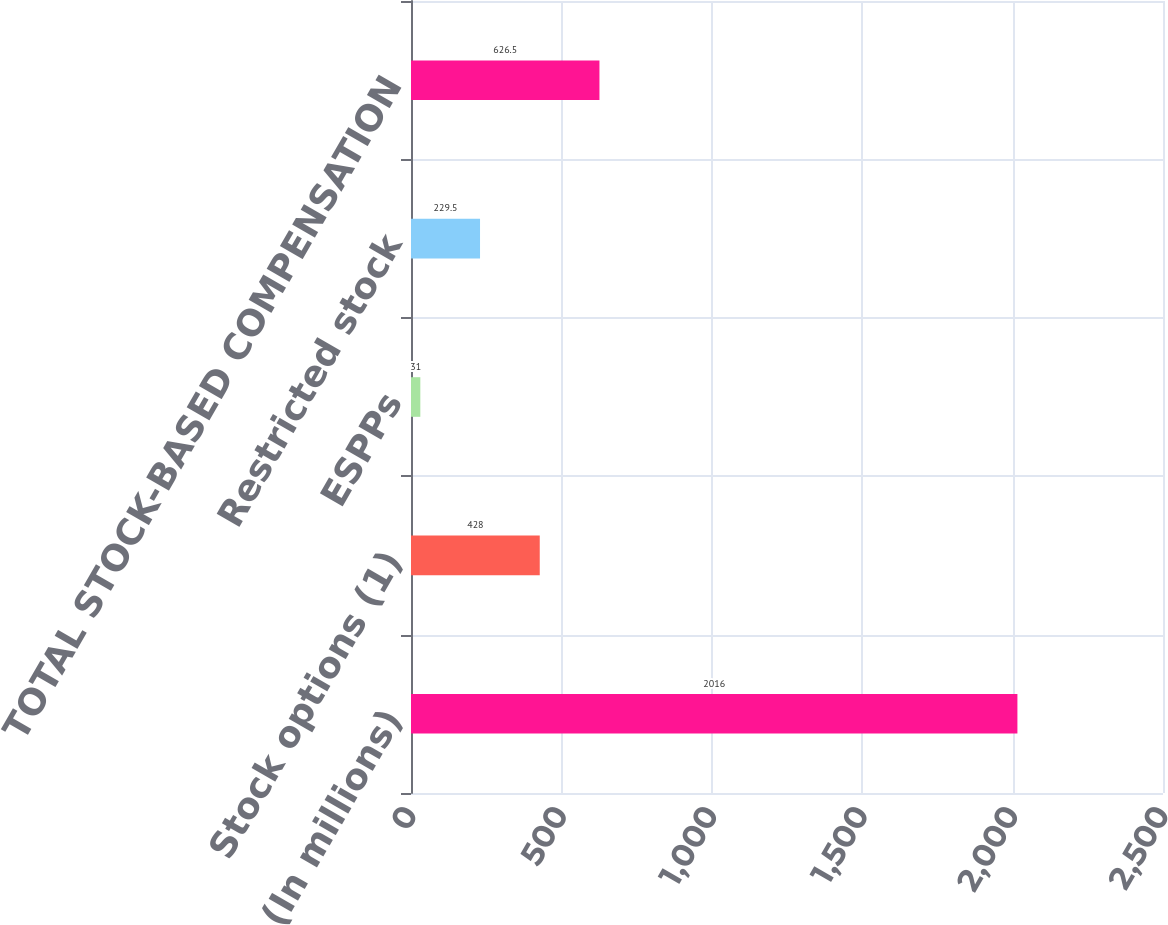<chart> <loc_0><loc_0><loc_500><loc_500><bar_chart><fcel>(In millions)<fcel>Stock options (1)<fcel>ESPPs<fcel>Restricted stock<fcel>TOTAL STOCK-BASED COMPENSATION<nl><fcel>2016<fcel>428<fcel>31<fcel>229.5<fcel>626.5<nl></chart> 